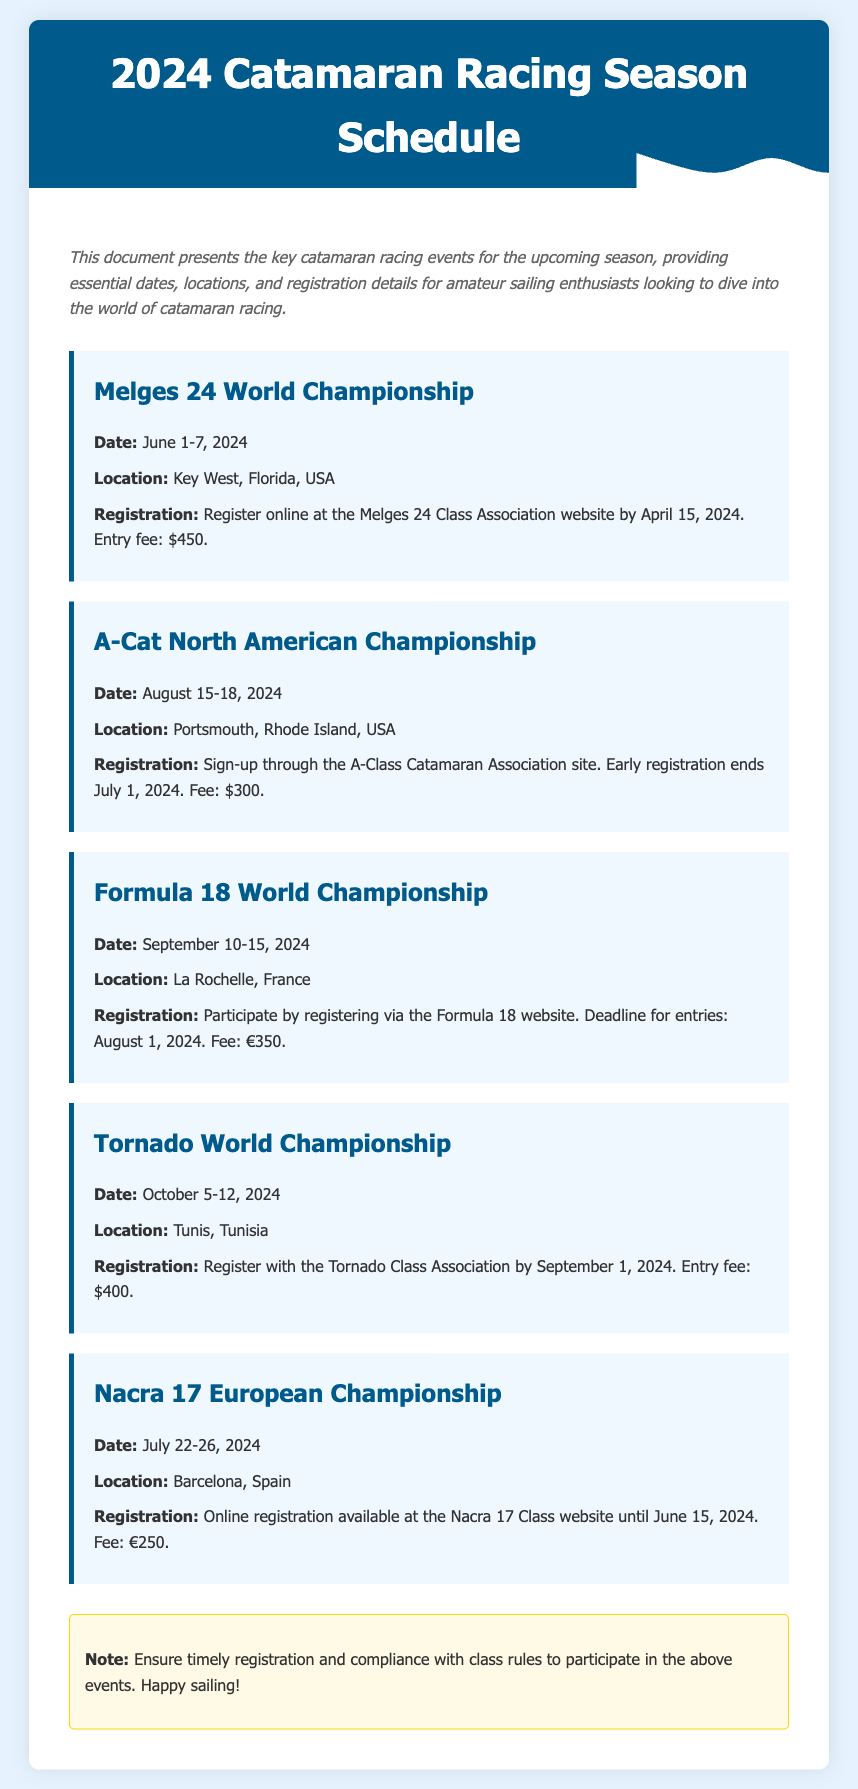What is the date of the Melges 24 World Championship? The date for the Melges 24 World Championship is explicitly listed in the document.
Answer: June 1-7, 2024 Where will the A-Cat North American Championship take place? The document provides location information for each event, including the A-Cat North American Championship.
Answer: Portsmouth, Rhode Island, USA What is the entry fee for the Formula 18 World Championship? The entry fee for the Formula 18 World Championship is specified in the registration details.
Answer: €350 When does online registration close for the Nacra 17 European Championship? The closing date for online registration is mentioned in the event details for the Nacra 17 European Championship.
Answer: June 15, 2024 How many days is the Tornado World Championship scheduled for? The document specifies the range of dates for each event, allowing for calculation of the event duration.
Answer: 7 days What is the registration website for the Melges 24 World Championship? The registration method for each event is provided, which includes the website link for the Melges 24 World Championship.
Answer: Melges 24 Class Association website Which event occurs in October? The document lists event dates, and October is clearly mentioned alongside specific events.
Answer: Tornado World Championship 